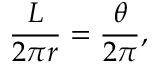Convert formula to latex. <formula><loc_0><loc_0><loc_500><loc_500>{ \frac { L } { 2 \pi r } } = { \frac { \theta } { 2 \pi } } ,</formula> 